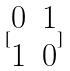Convert formula to latex. <formula><loc_0><loc_0><loc_500><loc_500>[ \begin{matrix} 0 & 1 \\ 1 & 0 \end{matrix} ]</formula> 